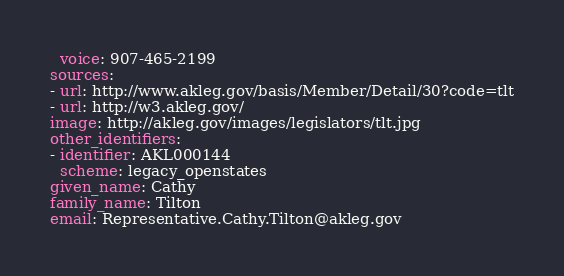<code> <loc_0><loc_0><loc_500><loc_500><_YAML_>  voice: 907-465-2199
sources:
- url: http://www.akleg.gov/basis/Member/Detail/30?code=tlt
- url: http://w3.akleg.gov/
image: http://akleg.gov/images/legislators/tlt.jpg
other_identifiers:
- identifier: AKL000144
  scheme: legacy_openstates
given_name: Cathy
family_name: Tilton
email: Representative.Cathy.Tilton@akleg.gov
</code> 